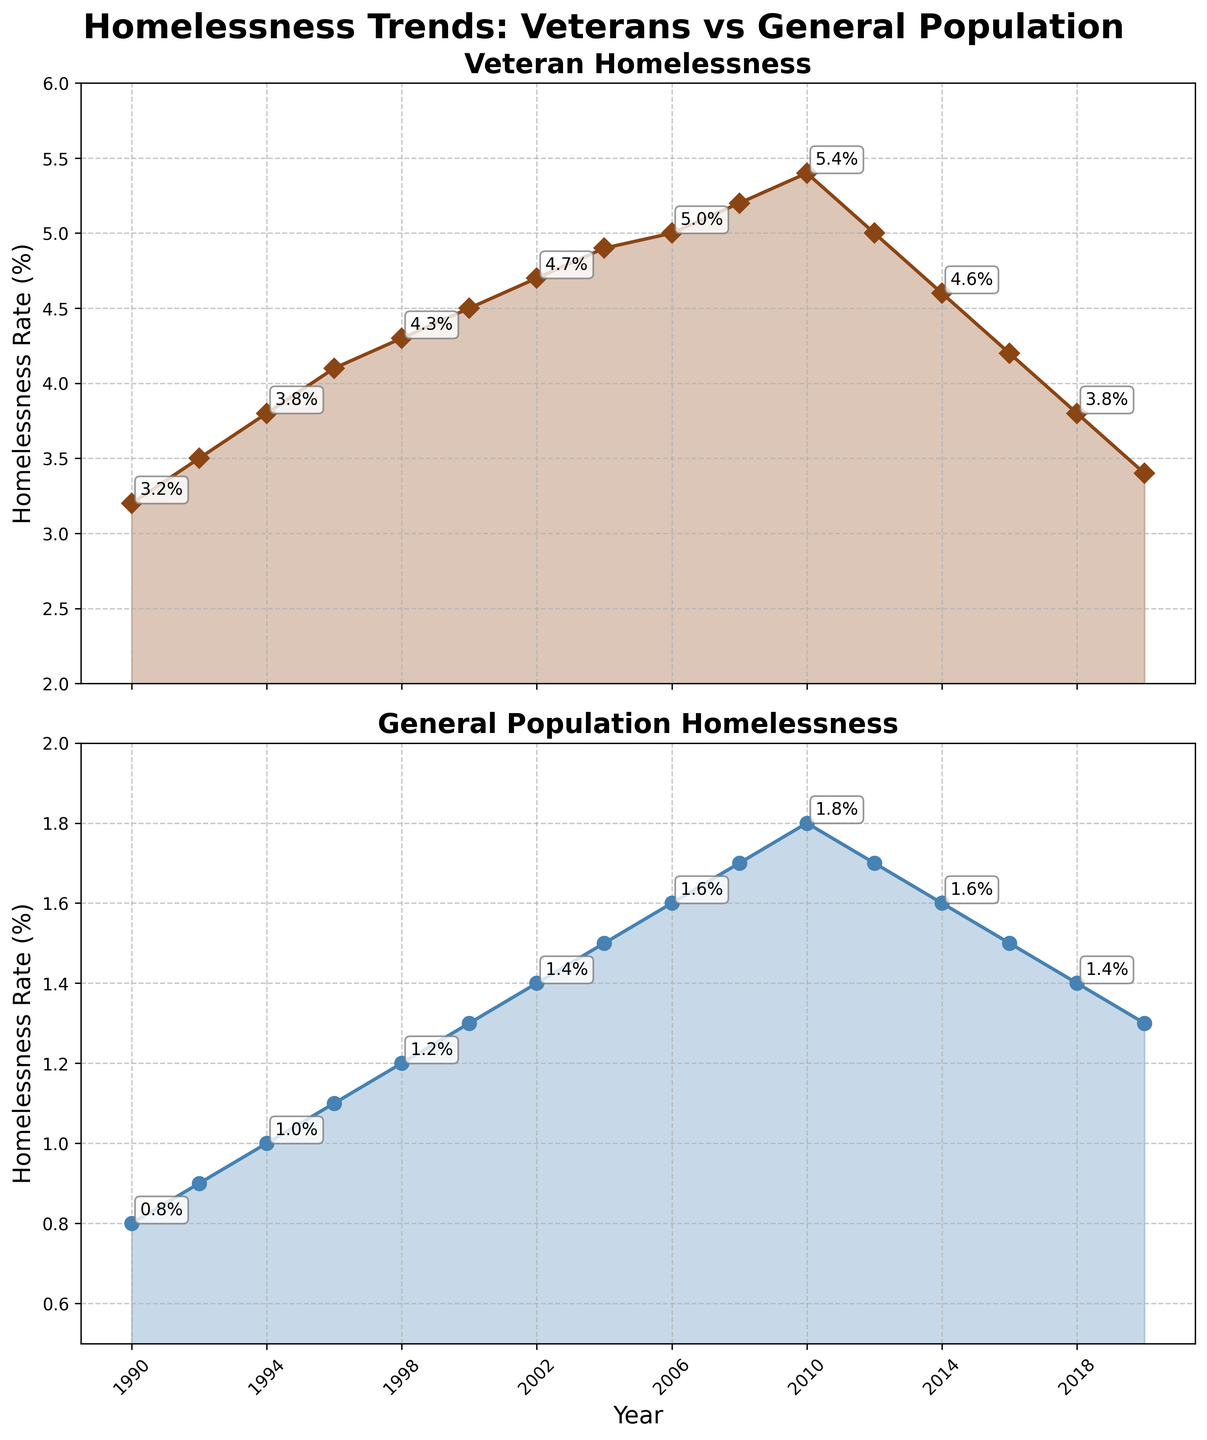What is the overall trend in veteran homelessness rates from 1990 to 2020? The veteran homelessness rates increased from 3.2% in 1990 to a peak of 5.4% in 2010 and then decreased to 3.4% by 2020. The overall trend shows an initial increase followed by a decrease.
Answer: Increase, then decrease Did the general population homelessness rate exceed 2% at any point? Looking at the plotted data in the figure, the general population homelessness rate never surpasses 2% during the time frame from 1990 to 2020.
Answer: No How does the rate of change in veteran homelessness from 1996 to 2000 compare with that from 2000 to 2004? From 1996 to 2000, the veteran homelessness rate increased by 0.4% (from 4.1% to 4.5%). From 2000 to 2004, it increased by another 0.4% (from 4.5% to 4.9%). Thus, the rate of change was the same in both intervals.
Answer: Same Was there ever a period when the veteran homelessness rate decreased while the general population homelessness rate increased? Yes, between the years 2010 and 2012, the veteran homelessness rate decreased from 5.4% to 5.0% while the general population homelessness rate decreased from 1.8% to 1.7%.
Answer: Yes, but both rates decreased together What was the highest value of veteran homelessness rate? The highest value of veteran homelessness rate as seen in the figure was in 2010, where it reached 5.4%.
Answer: 5.4% In which year did the veteran homelessness rate and general population homelessness rate both show a decreasing trend? Both the veteran and general population homelessness rates show a decreasing trend from 2010 to 2012, and again from 2012 to 2014.
Answer: 2010 to 2014 (both periods) What is the difference in homelessness rates between veterans and the general population in 1994? In 1994, the veteran homelessness rate was 3.8% and the general population homelessness rate was 1.0%. The difference is 3.8% - 1.0% = 2.8%.
Answer: 2.8% 